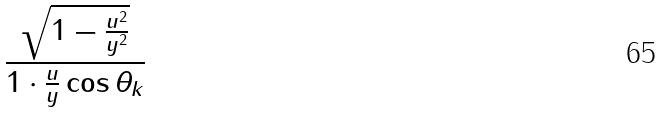<formula> <loc_0><loc_0><loc_500><loc_500>\frac { \sqrt { 1 - \frac { u ^ { 2 } } { y ^ { 2 } } } } { 1 \cdot \frac { u } { y } \cos \theta _ { k } }</formula> 